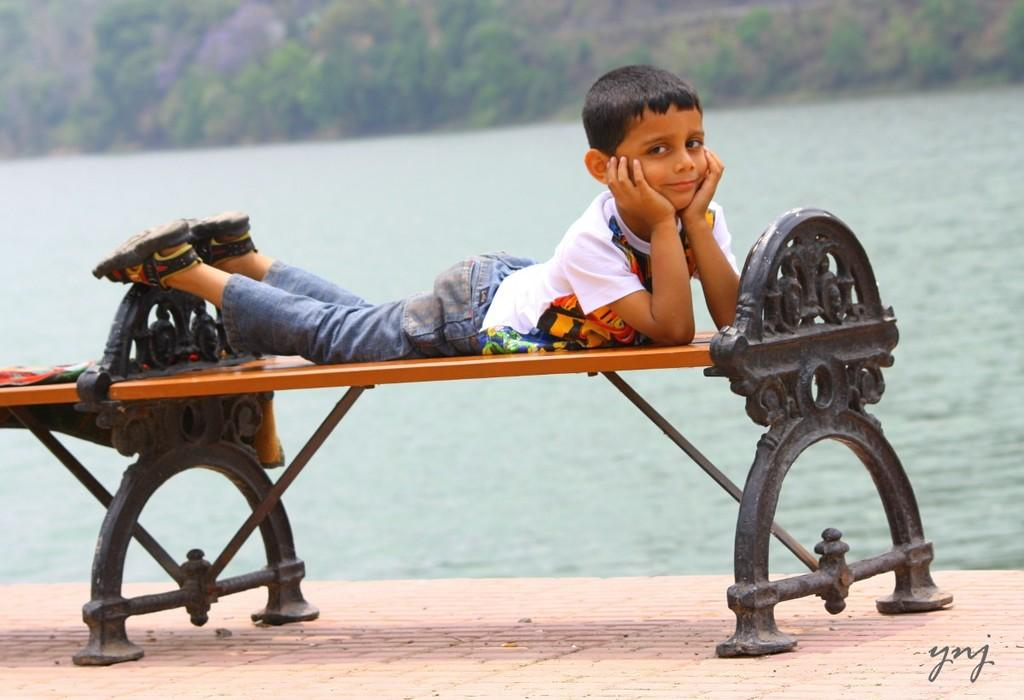Who is the main subject in the image? There is a boy in the image. What is the boy doing in the image? The boy is lying on a bench. What can be seen in the background of the image? There is water and trees visible in the background of the image. Where is the faucet located in the image? There is no faucet present in the image. How does the boy's breath affect the surrounding environment in the image? The image does not show the boy's breath or its effect on the environment. 